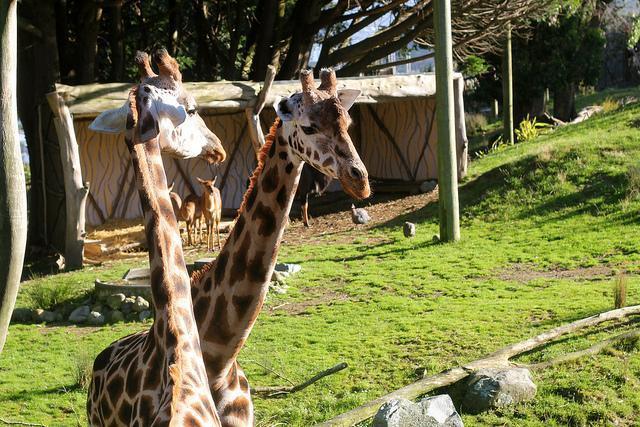How many giraffes are there?
Give a very brief answer. 2. How many people are wearing a jacket?
Give a very brief answer. 0. 